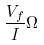Convert formula to latex. <formula><loc_0><loc_0><loc_500><loc_500>\frac { V _ { f } } { I } \Omega</formula> 